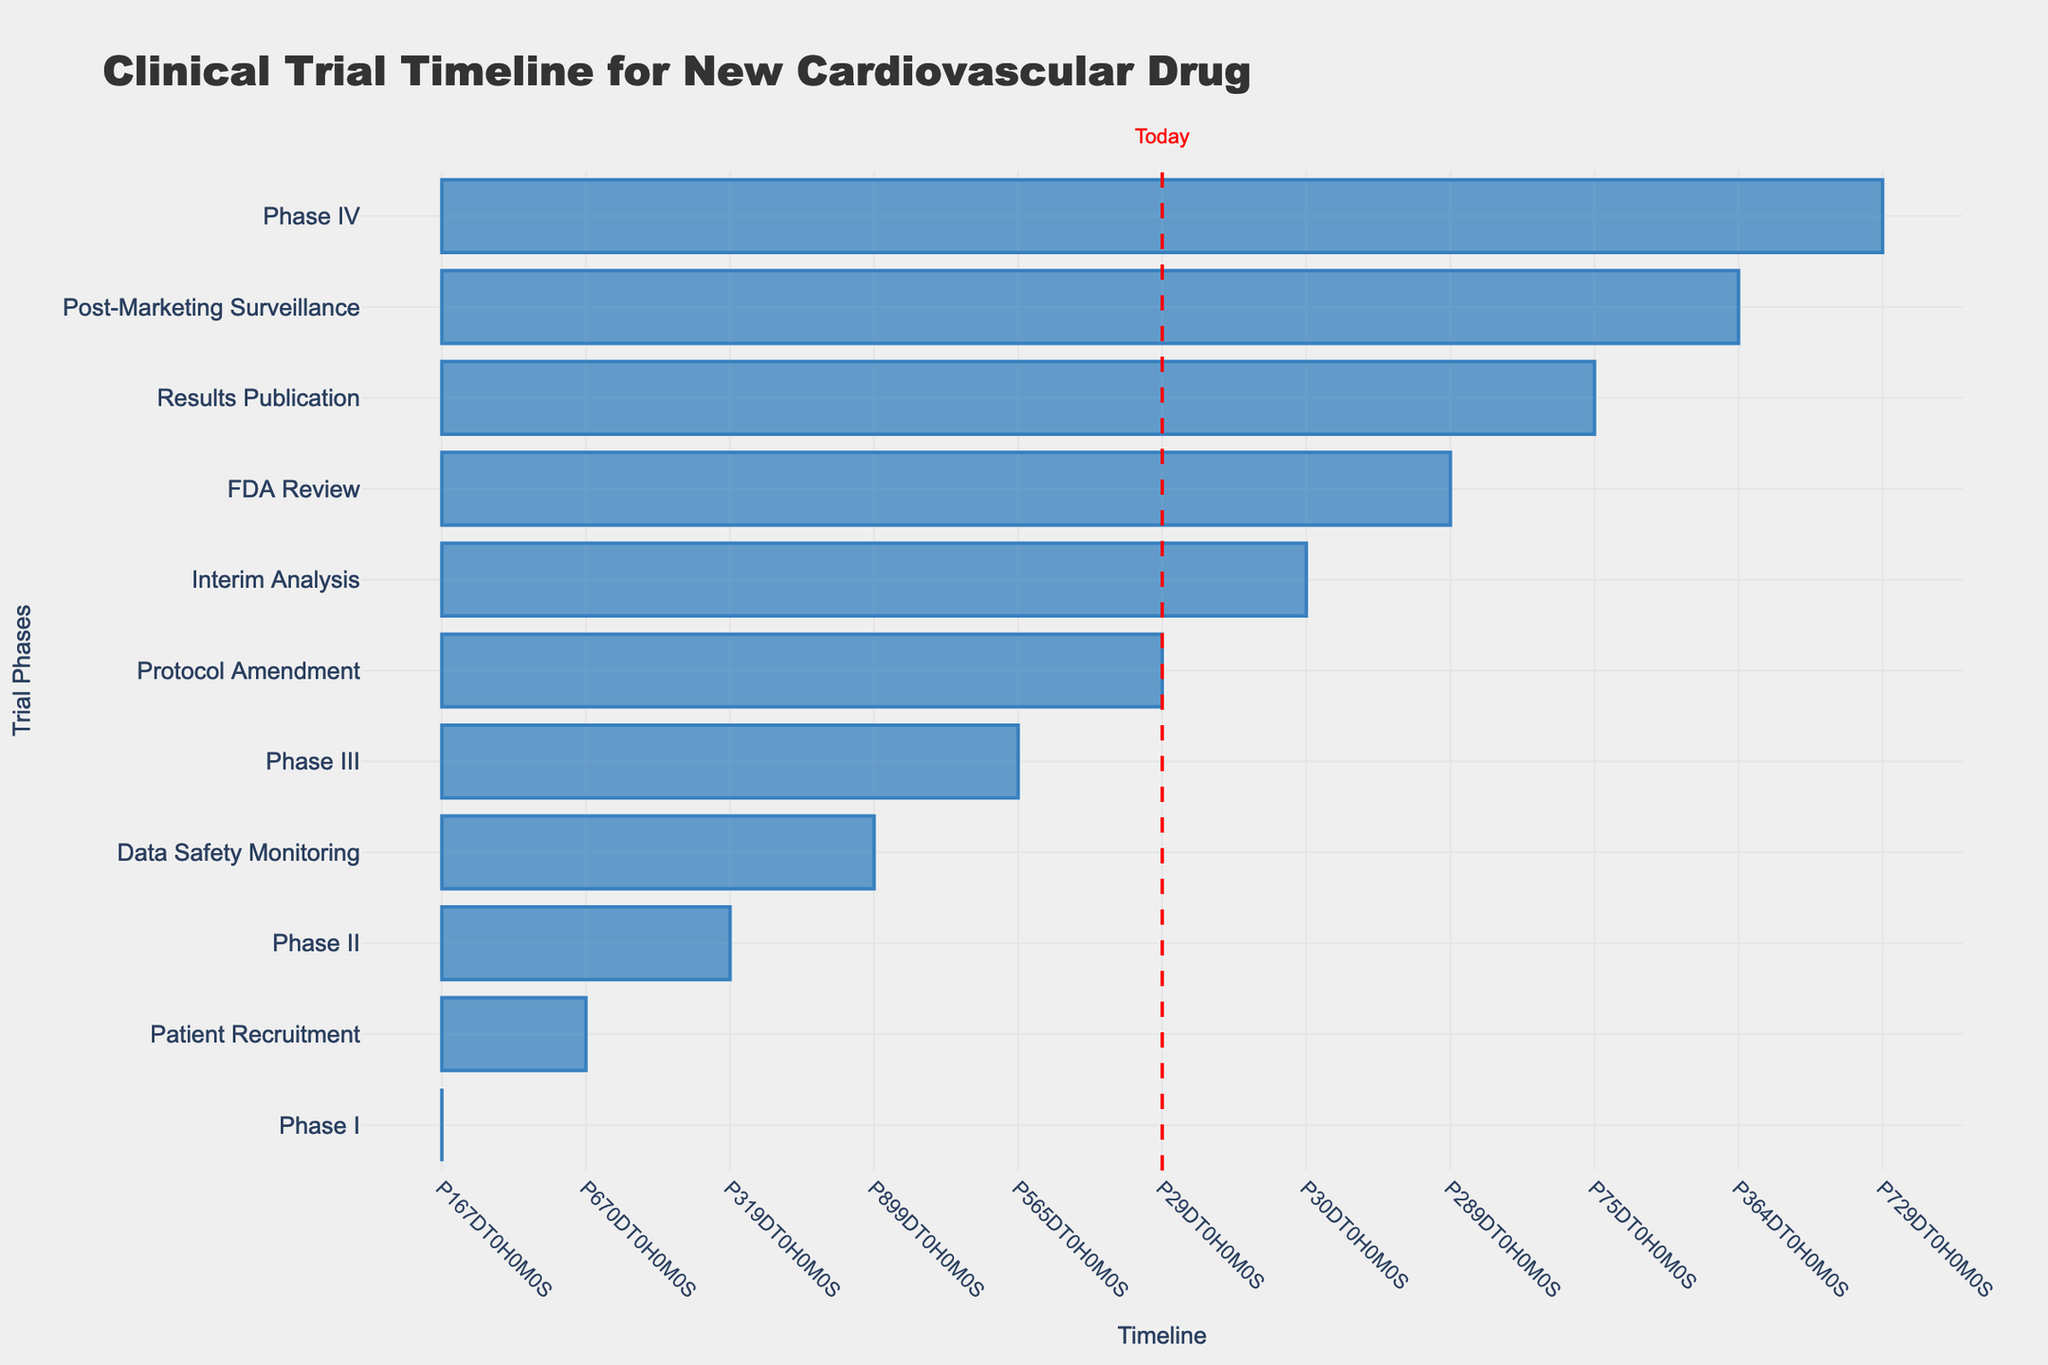What is the duration of Phase II? The duration of Phase II is calculated from its start date (April 15, 2022) to its end date (February 28, 2023). The total duration is approximately 10.5 months.
Answer: 10.5 months Which phase has the longest duration? By comparing the durations of each phase based on their start and end dates, the longest duration is found by checking the dates for Phase III, which runs from March 15, 2023, to September 30, 2024, totaling about 18.5 months.
Answer: Phase III Is the Patient Recruitment period longer than the Phase I duration? To determine this, we compare the Patient Recruitment period (March 1, 2022 - December 31, 2023) lasting about 22 months with Phase I (October 15, 2021 - March 31, 2022), which lasted about 5.5 months. Since 22 months > 5.5 months, the answer is yes.
Answer: Yes What is the total duration of the FDA Review phase and Post-Marketing Surveillance combined? The FDA Review lasts from October 15, 2024, to July 31, 2025 (approximately 9.5 months) and Post-Marketing Surveillance lasts from August 15, 2025, to August 14, 2026 (about 12 months). Adding these durations gives 9.5 + 12 = 21.5 months.
Answer: 21.5 months Does the Protocol Amendment occur between Phase I and Phase II? The Protocol Amendment occurs from June 1, 2023, to June 30, 2023. Phase I ends on March 31, 2022, and Phase II starts on April 15, 2023. Since June falls between the end of Phase I and the start of Phase II, the answer is yes.
Answer: Yes What is the average duration of the phases excluding Data Safety Monitoring? First, we calculate the durations of each remaining phase: Phase I (5.5 months), Phase II (10.5 months), Phase III (18.5 months), FDA Review (9.5 months), Post-Marketing Surveillance (12 months), and Phase IV (24 months). Adding these durations gives 5.5 + 10.5 + 18.5 + 9.5 + 12 + 24 = 70 months. Dividing by the number of phases (6) gives an average of 70/6 ≈ 11.67 months.
Answer: 11.67 months Which phase runs concurrently with the Data Safety Monitoring? Data Safety Monitoring runs from April 15, 2022, to September 30, 2024. The phases that start before or during this period are Phase II (April 15, 2022 - February 28, 2023) and Phase III (March 15, 2023 - September 30, 2024). Both phases are active during this time.
Answer: Phase II and Phase III When is the Interim Analysis planned, and how does it relate to Phase III? The Interim Analysis occurs from November 15, 2023, to December 15, 2023. Since it is scheduled within the timeline of Phase III, which runs from March 15, 2023, to September 30, 2024, it is closely related to the progress of Phase III as it assesses data partway through the trial.
Answer: Yes, it is planned during Phase III 